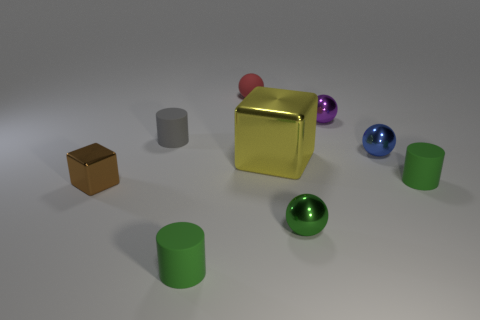There is a thing that is on the left side of the tiny green metallic sphere and in front of the small block; what is its shape? cylinder 